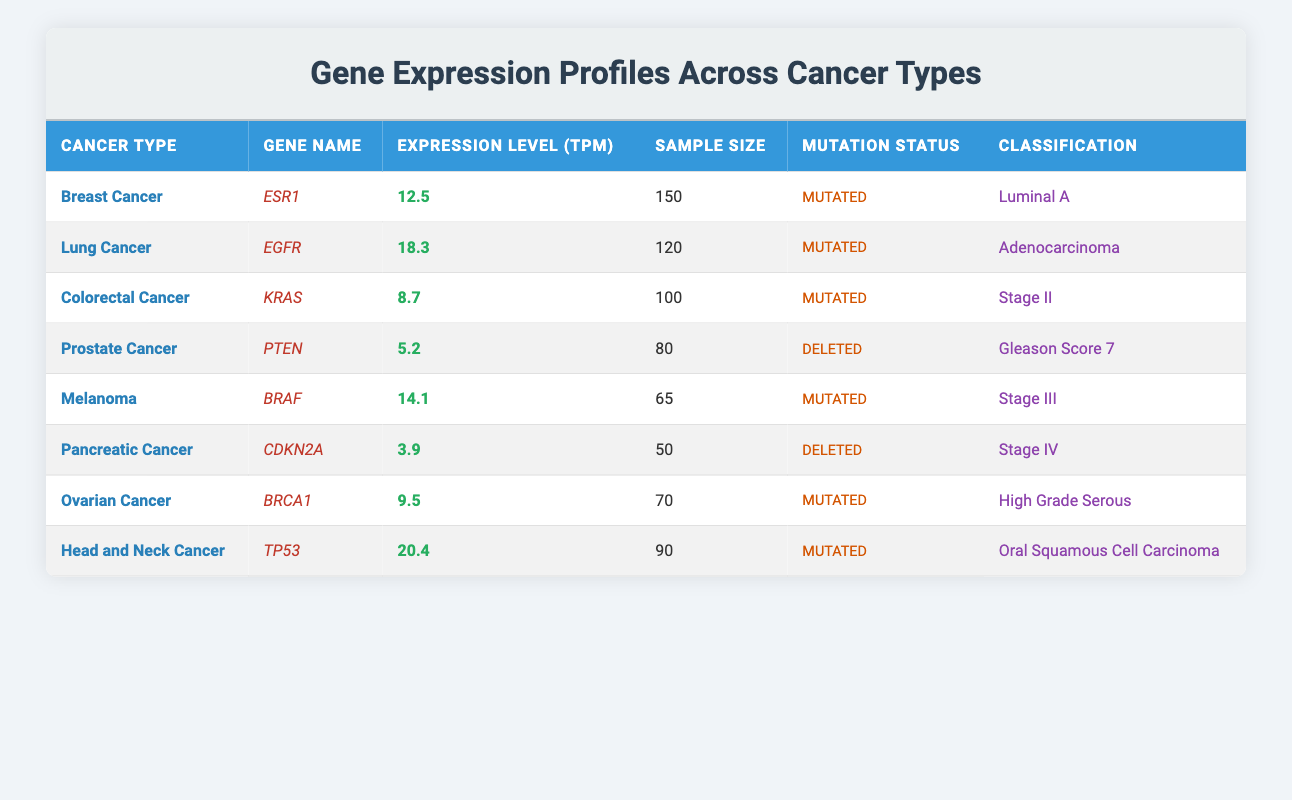What is the expression level of the gene BRAF in melanoma? The table indicates that the expression level of the gene BRAF in melanoma is 14.1.
Answer: 14.1 How many samples were used to obtain the expression profile for breast cancer? According to the table, the sample size for breast cancer is listed as 150.
Answer: 150 Is the gene CDKN2A deleted in pancreatic cancer? The table shows that the mutation status for CDKN2A in pancreatic cancer is marked as Deleted, indicating it is indeed deleted.
Answer: Yes What is the average expression level of mutated genes across the cancer types listed? The expression levels for mutated genes are: ESR1 (12.5), EGFR (18.3), KRAS (8.7), BRAF (14.1), BRCA1 (9.5), and TP53 (20.4). There are 6 mutated genes. The sum is 12.5 + 18.3 + 8.7 + 14.1 + 9.5 + 20.4 = 83.5. The average is 83.5 / 6 = 13.92.
Answer: 13.92 Which cancer type has the highest expression level, and what is that level? By comparing the expression levels, it is evident that head and neck cancer with gene TP53 has the highest expression level at 20.4.
Answer: Head and Neck Cancer, 20.4 How many cancer types listed have a gene with deleted mutation status? The table shows that there are two instances where a gene has a deleted mutation status: PTEN in prostate cancer and CDKN2A in pancreatic cancer. Thus, there are two cancer types with this status.
Answer: 2 What is the classification of the lung cancer gene EGFR? The classification for the gene EGFR in lung cancer, as per the table, is Adenocarcinoma.
Answer: Adenocarcinoma Which gene has the lowest expression level, and in which cancer type does it occur? The lowest expression level in the table is for the gene CDKN2A in pancreatic cancer, with a level of 3.9.
Answer: CDKN2A, Pancreatic Cancer, 3.9 